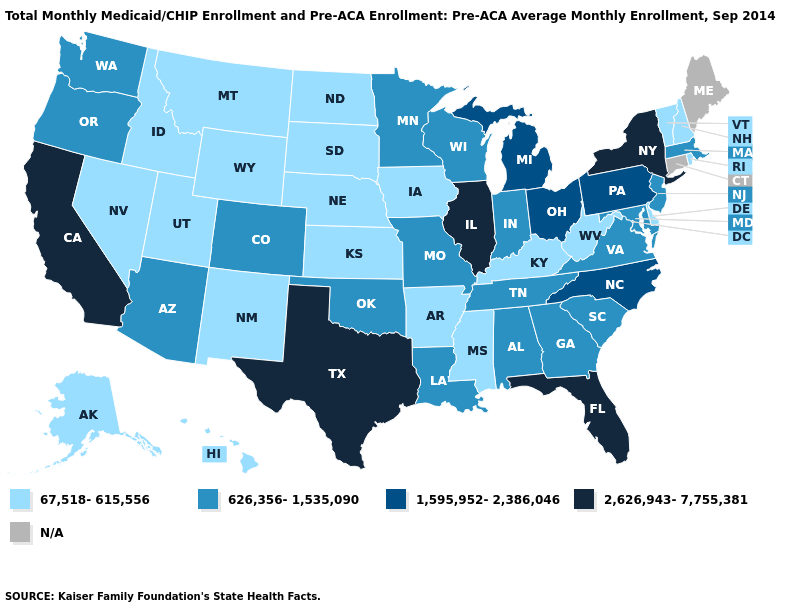What is the value of Wisconsin?
Write a very short answer. 626,356-1,535,090. Name the states that have a value in the range 67,518-615,556?
Write a very short answer. Alaska, Arkansas, Delaware, Hawaii, Idaho, Iowa, Kansas, Kentucky, Mississippi, Montana, Nebraska, Nevada, New Hampshire, New Mexico, North Dakota, Rhode Island, South Dakota, Utah, Vermont, West Virginia, Wyoming. Among the states that border New Mexico , does Oklahoma have the highest value?
Short answer required. No. Is the legend a continuous bar?
Give a very brief answer. No. What is the highest value in states that border Georgia?
Answer briefly. 2,626,943-7,755,381. What is the value of Nebraska?
Answer briefly. 67,518-615,556. Which states have the lowest value in the West?
Short answer required. Alaska, Hawaii, Idaho, Montana, Nevada, New Mexico, Utah, Wyoming. Which states have the lowest value in the West?
Be succinct. Alaska, Hawaii, Idaho, Montana, Nevada, New Mexico, Utah, Wyoming. Name the states that have a value in the range 1,595,952-2,386,046?
Give a very brief answer. Michigan, North Carolina, Ohio, Pennsylvania. Name the states that have a value in the range 2,626,943-7,755,381?
Write a very short answer. California, Florida, Illinois, New York, Texas. Name the states that have a value in the range N/A?
Short answer required. Connecticut, Maine. Which states hav the highest value in the MidWest?
Give a very brief answer. Illinois. What is the value of Wyoming?
Be succinct. 67,518-615,556. 